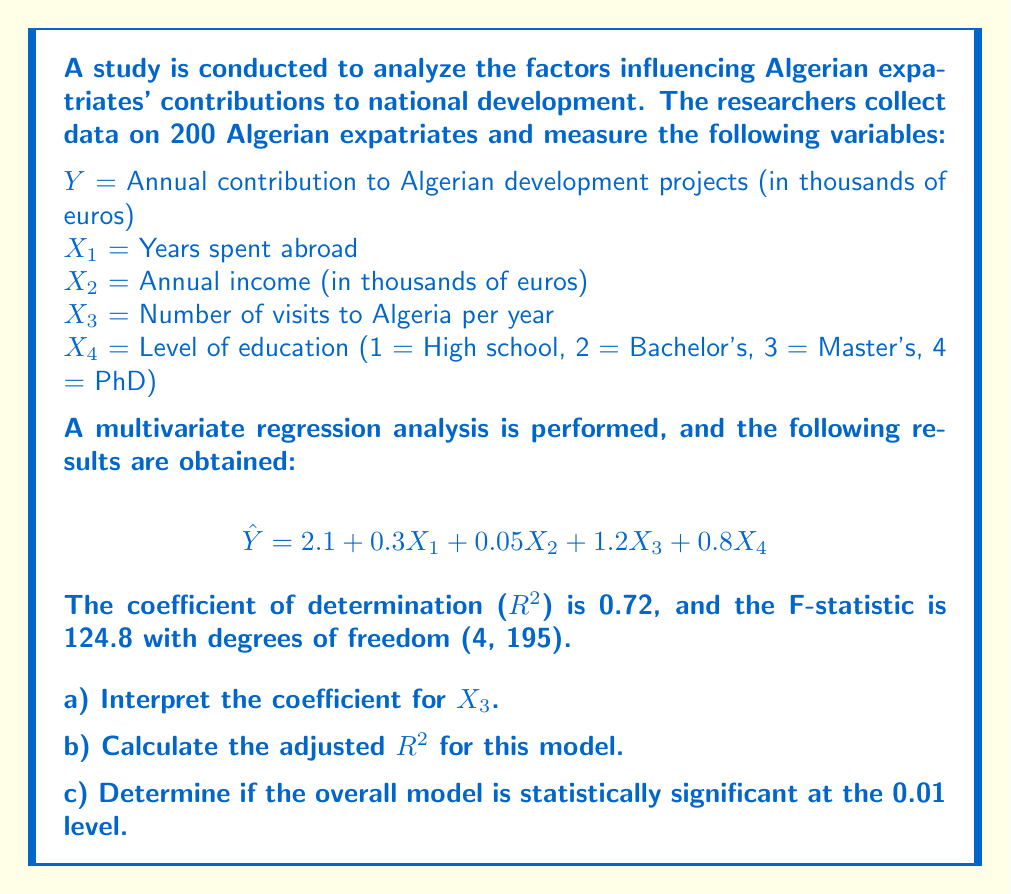Can you solve this math problem? Let's approach this question step by step:

a) Interpreting the coefficient for $X_3$:
The coefficient for $X_3$ is 1.2. This means that, on average, for each additional visit to Algeria per year, the annual contribution to Algerian development projects increases by 1.2 thousand euros, holding all other variables constant.

b) Calculating the adjusted $R^2$:
The adjusted $R^2$ takes into account the number of predictors in the model. The formula is:

$$R^2_{adj} = 1 - \frac{(1-R^2)(n-1)}{n-k-1}$$

Where:
$n$ = number of observations (200)
$k$ = number of predictors (4)
$R^2$ = 0.72

Plugging in the values:

$$R^2_{adj} = 1 - \frac{(1-0.72)(200-1)}{200-4-1}$$
$$R^2_{adj} = 1 - \frac{0.28 \times 199}{195}$$
$$R^2_{adj} = 1 - 0.2857$$
$$R^2_{adj} = 0.7143$$

c) Determining if the overall model is statistically significant:
To determine if the model is statistically significant, we compare the F-statistic to the critical F-value at the 0.01 level with degrees of freedom (4, 195).

The F-statistic is 124.8.

The critical F-value can be found in an F-distribution table or calculated using statistical software. For this problem, let's assume the critical F-value at the 0.01 level with df (4, 195) is approximately 3.41.

Since 124.8 > 3.41, we reject the null hypothesis and conclude that the overall model is statistically significant at the 0.01 level.
Answer: a) For each additional visit to Algeria per year, the annual contribution to Algerian development projects increases by 1.2 thousand euros, on average, holding all other variables constant.

b) The adjusted $R^2$ is 0.7143.

c) The overall model is statistically significant at the 0.01 level, as the F-statistic (124.8) is greater than the critical F-value (3.41). 